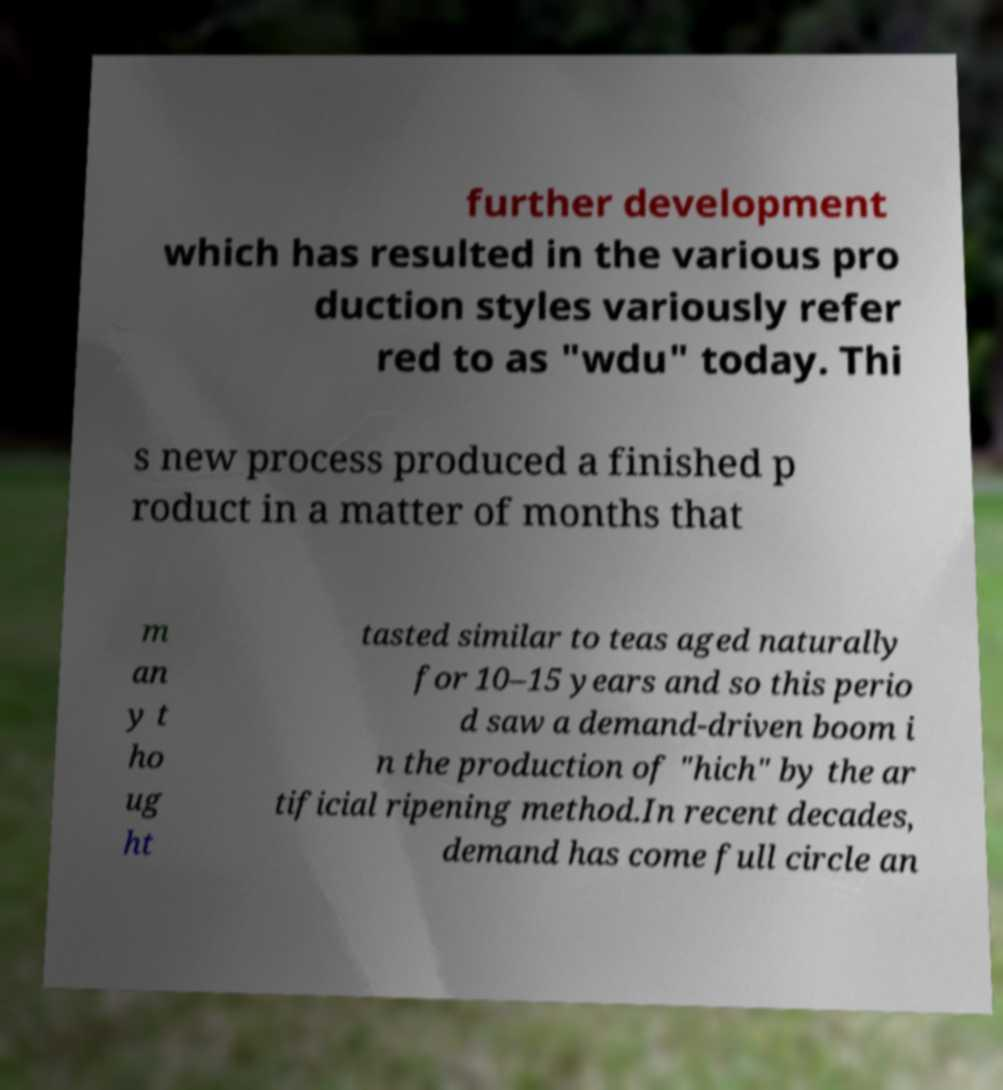What messages or text are displayed in this image? I need them in a readable, typed format. further development which has resulted in the various pro duction styles variously refer red to as "wdu" today. Thi s new process produced a finished p roduct in a matter of months that m an y t ho ug ht tasted similar to teas aged naturally for 10–15 years and so this perio d saw a demand-driven boom i n the production of "hich" by the ar tificial ripening method.In recent decades, demand has come full circle an 